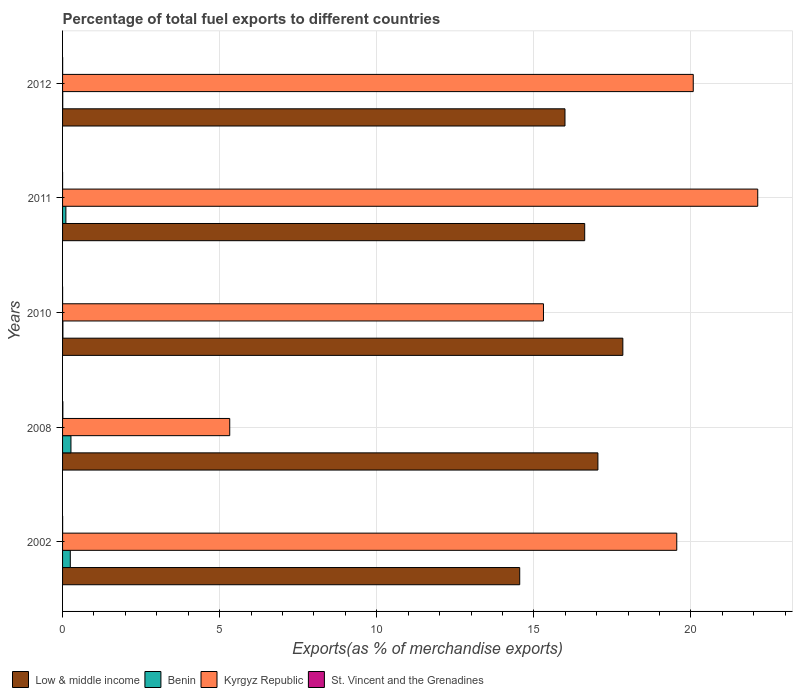How many groups of bars are there?
Offer a very short reply. 5. Are the number of bars on each tick of the Y-axis equal?
Keep it short and to the point. Yes. What is the percentage of exports to different countries in Kyrgyz Republic in 2002?
Your answer should be compact. 19.55. Across all years, what is the maximum percentage of exports to different countries in Kyrgyz Republic?
Your answer should be very brief. 22.12. Across all years, what is the minimum percentage of exports to different countries in Low & middle income?
Give a very brief answer. 14.55. What is the total percentage of exports to different countries in Benin in the graph?
Provide a short and direct response. 0.63. What is the difference between the percentage of exports to different countries in Benin in 2008 and that in 2012?
Give a very brief answer. 0.26. What is the difference between the percentage of exports to different countries in Kyrgyz Republic in 2011 and the percentage of exports to different countries in Benin in 2012?
Make the answer very short. 22.12. What is the average percentage of exports to different countries in Benin per year?
Your answer should be compact. 0.13. In the year 2008, what is the difference between the percentage of exports to different countries in Kyrgyz Republic and percentage of exports to different countries in Low & middle income?
Keep it short and to the point. -11.72. What is the ratio of the percentage of exports to different countries in Benin in 2010 to that in 2012?
Your response must be concise. 2.1. Is the percentage of exports to different countries in Benin in 2011 less than that in 2012?
Offer a terse response. No. What is the difference between the highest and the second highest percentage of exports to different countries in Low & middle income?
Ensure brevity in your answer.  0.79. What is the difference between the highest and the lowest percentage of exports to different countries in Benin?
Your answer should be compact. 0.26. In how many years, is the percentage of exports to different countries in Low & middle income greater than the average percentage of exports to different countries in Low & middle income taken over all years?
Make the answer very short. 3. What does the 4th bar from the top in 2002 represents?
Provide a short and direct response. Low & middle income. What does the 4th bar from the bottom in 2011 represents?
Your answer should be very brief. St. Vincent and the Grenadines. Is it the case that in every year, the sum of the percentage of exports to different countries in Low & middle income and percentage of exports to different countries in St. Vincent and the Grenadines is greater than the percentage of exports to different countries in Benin?
Provide a succinct answer. Yes. How many bars are there?
Ensure brevity in your answer.  20. How are the legend labels stacked?
Keep it short and to the point. Horizontal. What is the title of the graph?
Your response must be concise. Percentage of total fuel exports to different countries. Does "Suriname" appear as one of the legend labels in the graph?
Offer a very short reply. No. What is the label or title of the X-axis?
Make the answer very short. Exports(as % of merchandise exports). What is the Exports(as % of merchandise exports) in Low & middle income in 2002?
Your answer should be very brief. 14.55. What is the Exports(as % of merchandise exports) in Benin in 2002?
Ensure brevity in your answer.  0.25. What is the Exports(as % of merchandise exports) in Kyrgyz Republic in 2002?
Your answer should be compact. 19.55. What is the Exports(as % of merchandise exports) of St. Vincent and the Grenadines in 2002?
Provide a short and direct response. 0. What is the Exports(as % of merchandise exports) of Low & middle income in 2008?
Provide a short and direct response. 17.04. What is the Exports(as % of merchandise exports) of Benin in 2008?
Provide a short and direct response. 0.27. What is the Exports(as % of merchandise exports) of Kyrgyz Republic in 2008?
Make the answer very short. 5.32. What is the Exports(as % of merchandise exports) of St. Vincent and the Grenadines in 2008?
Your response must be concise. 0.01. What is the Exports(as % of merchandise exports) of Low & middle income in 2010?
Ensure brevity in your answer.  17.83. What is the Exports(as % of merchandise exports) of Benin in 2010?
Keep it short and to the point. 0.01. What is the Exports(as % of merchandise exports) of Kyrgyz Republic in 2010?
Make the answer very short. 15.3. What is the Exports(as % of merchandise exports) of St. Vincent and the Grenadines in 2010?
Provide a short and direct response. 0. What is the Exports(as % of merchandise exports) in Low & middle income in 2011?
Provide a succinct answer. 16.62. What is the Exports(as % of merchandise exports) in Benin in 2011?
Keep it short and to the point. 0.11. What is the Exports(as % of merchandise exports) in Kyrgyz Republic in 2011?
Provide a short and direct response. 22.12. What is the Exports(as % of merchandise exports) in St. Vincent and the Grenadines in 2011?
Make the answer very short. 0. What is the Exports(as % of merchandise exports) in Low & middle income in 2012?
Provide a succinct answer. 15.99. What is the Exports(as % of merchandise exports) of Benin in 2012?
Give a very brief answer. 0.01. What is the Exports(as % of merchandise exports) in Kyrgyz Republic in 2012?
Your answer should be compact. 20.07. What is the Exports(as % of merchandise exports) in St. Vincent and the Grenadines in 2012?
Keep it short and to the point. 0. Across all years, what is the maximum Exports(as % of merchandise exports) of Low & middle income?
Offer a terse response. 17.83. Across all years, what is the maximum Exports(as % of merchandise exports) of Benin?
Offer a very short reply. 0.27. Across all years, what is the maximum Exports(as % of merchandise exports) of Kyrgyz Republic?
Make the answer very short. 22.12. Across all years, what is the maximum Exports(as % of merchandise exports) in St. Vincent and the Grenadines?
Provide a succinct answer. 0.01. Across all years, what is the minimum Exports(as % of merchandise exports) in Low & middle income?
Ensure brevity in your answer.  14.55. Across all years, what is the minimum Exports(as % of merchandise exports) in Benin?
Your answer should be very brief. 0.01. Across all years, what is the minimum Exports(as % of merchandise exports) of Kyrgyz Republic?
Give a very brief answer. 5.32. Across all years, what is the minimum Exports(as % of merchandise exports) of St. Vincent and the Grenadines?
Ensure brevity in your answer.  0. What is the total Exports(as % of merchandise exports) of Low & middle income in the graph?
Offer a very short reply. 82.03. What is the total Exports(as % of merchandise exports) of Benin in the graph?
Provide a succinct answer. 0.63. What is the total Exports(as % of merchandise exports) of Kyrgyz Republic in the graph?
Give a very brief answer. 82.37. What is the total Exports(as % of merchandise exports) in St. Vincent and the Grenadines in the graph?
Keep it short and to the point. 0.01. What is the difference between the Exports(as % of merchandise exports) in Low & middle income in 2002 and that in 2008?
Provide a short and direct response. -2.49. What is the difference between the Exports(as % of merchandise exports) in Benin in 2002 and that in 2008?
Your answer should be compact. -0.02. What is the difference between the Exports(as % of merchandise exports) of Kyrgyz Republic in 2002 and that in 2008?
Provide a succinct answer. 14.23. What is the difference between the Exports(as % of merchandise exports) of St. Vincent and the Grenadines in 2002 and that in 2008?
Give a very brief answer. -0.01. What is the difference between the Exports(as % of merchandise exports) in Low & middle income in 2002 and that in 2010?
Provide a succinct answer. -3.28. What is the difference between the Exports(as % of merchandise exports) in Benin in 2002 and that in 2010?
Your answer should be compact. 0.24. What is the difference between the Exports(as % of merchandise exports) of Kyrgyz Republic in 2002 and that in 2010?
Offer a very short reply. 4.24. What is the difference between the Exports(as % of merchandise exports) in St. Vincent and the Grenadines in 2002 and that in 2010?
Give a very brief answer. 0. What is the difference between the Exports(as % of merchandise exports) of Low & middle income in 2002 and that in 2011?
Your response must be concise. -2.07. What is the difference between the Exports(as % of merchandise exports) in Benin in 2002 and that in 2011?
Provide a succinct answer. 0.14. What is the difference between the Exports(as % of merchandise exports) in Kyrgyz Republic in 2002 and that in 2011?
Your answer should be compact. -2.58. What is the difference between the Exports(as % of merchandise exports) of St. Vincent and the Grenadines in 2002 and that in 2011?
Ensure brevity in your answer.  0. What is the difference between the Exports(as % of merchandise exports) in Low & middle income in 2002 and that in 2012?
Provide a succinct answer. -1.44. What is the difference between the Exports(as % of merchandise exports) in Benin in 2002 and that in 2012?
Offer a very short reply. 0.24. What is the difference between the Exports(as % of merchandise exports) of Kyrgyz Republic in 2002 and that in 2012?
Your response must be concise. -0.52. What is the difference between the Exports(as % of merchandise exports) of St. Vincent and the Grenadines in 2002 and that in 2012?
Provide a succinct answer. -0. What is the difference between the Exports(as % of merchandise exports) in Low & middle income in 2008 and that in 2010?
Provide a short and direct response. -0.79. What is the difference between the Exports(as % of merchandise exports) of Benin in 2008 and that in 2010?
Your response must be concise. 0.26. What is the difference between the Exports(as % of merchandise exports) of Kyrgyz Republic in 2008 and that in 2010?
Your answer should be very brief. -9.98. What is the difference between the Exports(as % of merchandise exports) in St. Vincent and the Grenadines in 2008 and that in 2010?
Provide a succinct answer. 0.01. What is the difference between the Exports(as % of merchandise exports) of Low & middle income in 2008 and that in 2011?
Your answer should be very brief. 0.42. What is the difference between the Exports(as % of merchandise exports) of Benin in 2008 and that in 2011?
Give a very brief answer. 0.16. What is the difference between the Exports(as % of merchandise exports) in Kyrgyz Republic in 2008 and that in 2011?
Your answer should be compact. -16.8. What is the difference between the Exports(as % of merchandise exports) in St. Vincent and the Grenadines in 2008 and that in 2011?
Provide a succinct answer. 0.01. What is the difference between the Exports(as % of merchandise exports) of Low & middle income in 2008 and that in 2012?
Your answer should be compact. 1.05. What is the difference between the Exports(as % of merchandise exports) of Benin in 2008 and that in 2012?
Your response must be concise. 0.26. What is the difference between the Exports(as % of merchandise exports) of Kyrgyz Republic in 2008 and that in 2012?
Provide a succinct answer. -14.75. What is the difference between the Exports(as % of merchandise exports) in St. Vincent and the Grenadines in 2008 and that in 2012?
Your answer should be compact. 0.01. What is the difference between the Exports(as % of merchandise exports) in Low & middle income in 2010 and that in 2011?
Offer a terse response. 1.21. What is the difference between the Exports(as % of merchandise exports) of Benin in 2010 and that in 2011?
Offer a terse response. -0.09. What is the difference between the Exports(as % of merchandise exports) in Kyrgyz Republic in 2010 and that in 2011?
Offer a very short reply. -6.82. What is the difference between the Exports(as % of merchandise exports) of St. Vincent and the Grenadines in 2010 and that in 2011?
Offer a terse response. 0. What is the difference between the Exports(as % of merchandise exports) in Low & middle income in 2010 and that in 2012?
Offer a very short reply. 1.84. What is the difference between the Exports(as % of merchandise exports) in Benin in 2010 and that in 2012?
Ensure brevity in your answer.  0.01. What is the difference between the Exports(as % of merchandise exports) of Kyrgyz Republic in 2010 and that in 2012?
Give a very brief answer. -4.77. What is the difference between the Exports(as % of merchandise exports) in St. Vincent and the Grenadines in 2010 and that in 2012?
Provide a succinct answer. -0. What is the difference between the Exports(as % of merchandise exports) of Low & middle income in 2011 and that in 2012?
Your response must be concise. 0.63. What is the difference between the Exports(as % of merchandise exports) in Benin in 2011 and that in 2012?
Your response must be concise. 0.1. What is the difference between the Exports(as % of merchandise exports) of Kyrgyz Republic in 2011 and that in 2012?
Give a very brief answer. 2.05. What is the difference between the Exports(as % of merchandise exports) of St. Vincent and the Grenadines in 2011 and that in 2012?
Provide a short and direct response. -0. What is the difference between the Exports(as % of merchandise exports) of Low & middle income in 2002 and the Exports(as % of merchandise exports) of Benin in 2008?
Provide a succinct answer. 14.28. What is the difference between the Exports(as % of merchandise exports) of Low & middle income in 2002 and the Exports(as % of merchandise exports) of Kyrgyz Republic in 2008?
Your answer should be very brief. 9.23. What is the difference between the Exports(as % of merchandise exports) of Low & middle income in 2002 and the Exports(as % of merchandise exports) of St. Vincent and the Grenadines in 2008?
Provide a succinct answer. 14.54. What is the difference between the Exports(as % of merchandise exports) in Benin in 2002 and the Exports(as % of merchandise exports) in Kyrgyz Republic in 2008?
Provide a succinct answer. -5.07. What is the difference between the Exports(as % of merchandise exports) of Benin in 2002 and the Exports(as % of merchandise exports) of St. Vincent and the Grenadines in 2008?
Keep it short and to the point. 0.24. What is the difference between the Exports(as % of merchandise exports) in Kyrgyz Republic in 2002 and the Exports(as % of merchandise exports) in St. Vincent and the Grenadines in 2008?
Offer a terse response. 19.54. What is the difference between the Exports(as % of merchandise exports) in Low & middle income in 2002 and the Exports(as % of merchandise exports) in Benin in 2010?
Offer a terse response. 14.54. What is the difference between the Exports(as % of merchandise exports) in Low & middle income in 2002 and the Exports(as % of merchandise exports) in Kyrgyz Republic in 2010?
Make the answer very short. -0.76. What is the difference between the Exports(as % of merchandise exports) in Low & middle income in 2002 and the Exports(as % of merchandise exports) in St. Vincent and the Grenadines in 2010?
Your response must be concise. 14.55. What is the difference between the Exports(as % of merchandise exports) in Benin in 2002 and the Exports(as % of merchandise exports) in Kyrgyz Republic in 2010?
Keep it short and to the point. -15.06. What is the difference between the Exports(as % of merchandise exports) of Benin in 2002 and the Exports(as % of merchandise exports) of St. Vincent and the Grenadines in 2010?
Offer a terse response. 0.24. What is the difference between the Exports(as % of merchandise exports) of Kyrgyz Republic in 2002 and the Exports(as % of merchandise exports) of St. Vincent and the Grenadines in 2010?
Your answer should be compact. 19.55. What is the difference between the Exports(as % of merchandise exports) in Low & middle income in 2002 and the Exports(as % of merchandise exports) in Benin in 2011?
Give a very brief answer. 14.44. What is the difference between the Exports(as % of merchandise exports) of Low & middle income in 2002 and the Exports(as % of merchandise exports) of Kyrgyz Republic in 2011?
Keep it short and to the point. -7.58. What is the difference between the Exports(as % of merchandise exports) of Low & middle income in 2002 and the Exports(as % of merchandise exports) of St. Vincent and the Grenadines in 2011?
Keep it short and to the point. 14.55. What is the difference between the Exports(as % of merchandise exports) in Benin in 2002 and the Exports(as % of merchandise exports) in Kyrgyz Republic in 2011?
Your response must be concise. -21.88. What is the difference between the Exports(as % of merchandise exports) of Benin in 2002 and the Exports(as % of merchandise exports) of St. Vincent and the Grenadines in 2011?
Give a very brief answer. 0.25. What is the difference between the Exports(as % of merchandise exports) of Kyrgyz Republic in 2002 and the Exports(as % of merchandise exports) of St. Vincent and the Grenadines in 2011?
Make the answer very short. 19.55. What is the difference between the Exports(as % of merchandise exports) in Low & middle income in 2002 and the Exports(as % of merchandise exports) in Benin in 2012?
Your response must be concise. 14.54. What is the difference between the Exports(as % of merchandise exports) in Low & middle income in 2002 and the Exports(as % of merchandise exports) in Kyrgyz Republic in 2012?
Your response must be concise. -5.52. What is the difference between the Exports(as % of merchandise exports) in Low & middle income in 2002 and the Exports(as % of merchandise exports) in St. Vincent and the Grenadines in 2012?
Offer a terse response. 14.55. What is the difference between the Exports(as % of merchandise exports) in Benin in 2002 and the Exports(as % of merchandise exports) in Kyrgyz Republic in 2012?
Give a very brief answer. -19.83. What is the difference between the Exports(as % of merchandise exports) in Benin in 2002 and the Exports(as % of merchandise exports) in St. Vincent and the Grenadines in 2012?
Keep it short and to the point. 0.24. What is the difference between the Exports(as % of merchandise exports) in Kyrgyz Republic in 2002 and the Exports(as % of merchandise exports) in St. Vincent and the Grenadines in 2012?
Ensure brevity in your answer.  19.55. What is the difference between the Exports(as % of merchandise exports) of Low & middle income in 2008 and the Exports(as % of merchandise exports) of Benin in 2010?
Ensure brevity in your answer.  17.03. What is the difference between the Exports(as % of merchandise exports) in Low & middle income in 2008 and the Exports(as % of merchandise exports) in Kyrgyz Republic in 2010?
Ensure brevity in your answer.  1.73. What is the difference between the Exports(as % of merchandise exports) of Low & middle income in 2008 and the Exports(as % of merchandise exports) of St. Vincent and the Grenadines in 2010?
Give a very brief answer. 17.04. What is the difference between the Exports(as % of merchandise exports) of Benin in 2008 and the Exports(as % of merchandise exports) of Kyrgyz Republic in 2010?
Your answer should be very brief. -15.04. What is the difference between the Exports(as % of merchandise exports) in Benin in 2008 and the Exports(as % of merchandise exports) in St. Vincent and the Grenadines in 2010?
Your answer should be compact. 0.27. What is the difference between the Exports(as % of merchandise exports) of Kyrgyz Republic in 2008 and the Exports(as % of merchandise exports) of St. Vincent and the Grenadines in 2010?
Make the answer very short. 5.32. What is the difference between the Exports(as % of merchandise exports) in Low & middle income in 2008 and the Exports(as % of merchandise exports) in Benin in 2011?
Your response must be concise. 16.93. What is the difference between the Exports(as % of merchandise exports) in Low & middle income in 2008 and the Exports(as % of merchandise exports) in Kyrgyz Republic in 2011?
Provide a short and direct response. -5.09. What is the difference between the Exports(as % of merchandise exports) of Low & middle income in 2008 and the Exports(as % of merchandise exports) of St. Vincent and the Grenadines in 2011?
Provide a succinct answer. 17.04. What is the difference between the Exports(as % of merchandise exports) in Benin in 2008 and the Exports(as % of merchandise exports) in Kyrgyz Republic in 2011?
Your answer should be very brief. -21.86. What is the difference between the Exports(as % of merchandise exports) in Benin in 2008 and the Exports(as % of merchandise exports) in St. Vincent and the Grenadines in 2011?
Keep it short and to the point. 0.27. What is the difference between the Exports(as % of merchandise exports) of Kyrgyz Republic in 2008 and the Exports(as % of merchandise exports) of St. Vincent and the Grenadines in 2011?
Ensure brevity in your answer.  5.32. What is the difference between the Exports(as % of merchandise exports) in Low & middle income in 2008 and the Exports(as % of merchandise exports) in Benin in 2012?
Your response must be concise. 17.03. What is the difference between the Exports(as % of merchandise exports) in Low & middle income in 2008 and the Exports(as % of merchandise exports) in Kyrgyz Republic in 2012?
Provide a short and direct response. -3.03. What is the difference between the Exports(as % of merchandise exports) of Low & middle income in 2008 and the Exports(as % of merchandise exports) of St. Vincent and the Grenadines in 2012?
Your response must be concise. 17.04. What is the difference between the Exports(as % of merchandise exports) in Benin in 2008 and the Exports(as % of merchandise exports) in Kyrgyz Republic in 2012?
Your answer should be very brief. -19.81. What is the difference between the Exports(as % of merchandise exports) of Benin in 2008 and the Exports(as % of merchandise exports) of St. Vincent and the Grenadines in 2012?
Provide a short and direct response. 0.26. What is the difference between the Exports(as % of merchandise exports) of Kyrgyz Republic in 2008 and the Exports(as % of merchandise exports) of St. Vincent and the Grenadines in 2012?
Ensure brevity in your answer.  5.32. What is the difference between the Exports(as % of merchandise exports) of Low & middle income in 2010 and the Exports(as % of merchandise exports) of Benin in 2011?
Provide a short and direct response. 17.73. What is the difference between the Exports(as % of merchandise exports) in Low & middle income in 2010 and the Exports(as % of merchandise exports) in Kyrgyz Republic in 2011?
Give a very brief answer. -4.29. What is the difference between the Exports(as % of merchandise exports) of Low & middle income in 2010 and the Exports(as % of merchandise exports) of St. Vincent and the Grenadines in 2011?
Ensure brevity in your answer.  17.83. What is the difference between the Exports(as % of merchandise exports) in Benin in 2010 and the Exports(as % of merchandise exports) in Kyrgyz Republic in 2011?
Offer a very short reply. -22.11. What is the difference between the Exports(as % of merchandise exports) of Benin in 2010 and the Exports(as % of merchandise exports) of St. Vincent and the Grenadines in 2011?
Your answer should be very brief. 0.01. What is the difference between the Exports(as % of merchandise exports) of Kyrgyz Republic in 2010 and the Exports(as % of merchandise exports) of St. Vincent and the Grenadines in 2011?
Offer a very short reply. 15.3. What is the difference between the Exports(as % of merchandise exports) of Low & middle income in 2010 and the Exports(as % of merchandise exports) of Benin in 2012?
Offer a terse response. 17.83. What is the difference between the Exports(as % of merchandise exports) in Low & middle income in 2010 and the Exports(as % of merchandise exports) in Kyrgyz Republic in 2012?
Your answer should be very brief. -2.24. What is the difference between the Exports(as % of merchandise exports) of Low & middle income in 2010 and the Exports(as % of merchandise exports) of St. Vincent and the Grenadines in 2012?
Keep it short and to the point. 17.83. What is the difference between the Exports(as % of merchandise exports) of Benin in 2010 and the Exports(as % of merchandise exports) of Kyrgyz Republic in 2012?
Offer a terse response. -20.06. What is the difference between the Exports(as % of merchandise exports) of Benin in 2010 and the Exports(as % of merchandise exports) of St. Vincent and the Grenadines in 2012?
Keep it short and to the point. 0.01. What is the difference between the Exports(as % of merchandise exports) in Kyrgyz Republic in 2010 and the Exports(as % of merchandise exports) in St. Vincent and the Grenadines in 2012?
Offer a terse response. 15.3. What is the difference between the Exports(as % of merchandise exports) of Low & middle income in 2011 and the Exports(as % of merchandise exports) of Benin in 2012?
Keep it short and to the point. 16.61. What is the difference between the Exports(as % of merchandise exports) of Low & middle income in 2011 and the Exports(as % of merchandise exports) of Kyrgyz Republic in 2012?
Provide a short and direct response. -3.45. What is the difference between the Exports(as % of merchandise exports) in Low & middle income in 2011 and the Exports(as % of merchandise exports) in St. Vincent and the Grenadines in 2012?
Provide a succinct answer. 16.62. What is the difference between the Exports(as % of merchandise exports) of Benin in 2011 and the Exports(as % of merchandise exports) of Kyrgyz Republic in 2012?
Give a very brief answer. -19.97. What is the difference between the Exports(as % of merchandise exports) in Benin in 2011 and the Exports(as % of merchandise exports) in St. Vincent and the Grenadines in 2012?
Keep it short and to the point. 0.1. What is the difference between the Exports(as % of merchandise exports) in Kyrgyz Republic in 2011 and the Exports(as % of merchandise exports) in St. Vincent and the Grenadines in 2012?
Ensure brevity in your answer.  22.12. What is the average Exports(as % of merchandise exports) of Low & middle income per year?
Offer a very short reply. 16.41. What is the average Exports(as % of merchandise exports) of Benin per year?
Offer a very short reply. 0.13. What is the average Exports(as % of merchandise exports) in Kyrgyz Republic per year?
Your answer should be compact. 16.47. What is the average Exports(as % of merchandise exports) of St. Vincent and the Grenadines per year?
Your answer should be very brief. 0. In the year 2002, what is the difference between the Exports(as % of merchandise exports) of Low & middle income and Exports(as % of merchandise exports) of Benin?
Make the answer very short. 14.3. In the year 2002, what is the difference between the Exports(as % of merchandise exports) of Low & middle income and Exports(as % of merchandise exports) of Kyrgyz Republic?
Offer a very short reply. -5. In the year 2002, what is the difference between the Exports(as % of merchandise exports) of Low & middle income and Exports(as % of merchandise exports) of St. Vincent and the Grenadines?
Give a very brief answer. 14.55. In the year 2002, what is the difference between the Exports(as % of merchandise exports) of Benin and Exports(as % of merchandise exports) of Kyrgyz Republic?
Offer a terse response. -19.3. In the year 2002, what is the difference between the Exports(as % of merchandise exports) in Benin and Exports(as % of merchandise exports) in St. Vincent and the Grenadines?
Ensure brevity in your answer.  0.24. In the year 2002, what is the difference between the Exports(as % of merchandise exports) in Kyrgyz Republic and Exports(as % of merchandise exports) in St. Vincent and the Grenadines?
Offer a very short reply. 19.55. In the year 2008, what is the difference between the Exports(as % of merchandise exports) in Low & middle income and Exports(as % of merchandise exports) in Benin?
Your answer should be compact. 16.77. In the year 2008, what is the difference between the Exports(as % of merchandise exports) of Low & middle income and Exports(as % of merchandise exports) of Kyrgyz Republic?
Ensure brevity in your answer.  11.72. In the year 2008, what is the difference between the Exports(as % of merchandise exports) in Low & middle income and Exports(as % of merchandise exports) in St. Vincent and the Grenadines?
Your response must be concise. 17.03. In the year 2008, what is the difference between the Exports(as % of merchandise exports) of Benin and Exports(as % of merchandise exports) of Kyrgyz Republic?
Your response must be concise. -5.05. In the year 2008, what is the difference between the Exports(as % of merchandise exports) in Benin and Exports(as % of merchandise exports) in St. Vincent and the Grenadines?
Provide a succinct answer. 0.26. In the year 2008, what is the difference between the Exports(as % of merchandise exports) in Kyrgyz Republic and Exports(as % of merchandise exports) in St. Vincent and the Grenadines?
Your answer should be compact. 5.31. In the year 2010, what is the difference between the Exports(as % of merchandise exports) in Low & middle income and Exports(as % of merchandise exports) in Benin?
Provide a succinct answer. 17.82. In the year 2010, what is the difference between the Exports(as % of merchandise exports) in Low & middle income and Exports(as % of merchandise exports) in Kyrgyz Republic?
Provide a succinct answer. 2.53. In the year 2010, what is the difference between the Exports(as % of merchandise exports) in Low & middle income and Exports(as % of merchandise exports) in St. Vincent and the Grenadines?
Keep it short and to the point. 17.83. In the year 2010, what is the difference between the Exports(as % of merchandise exports) in Benin and Exports(as % of merchandise exports) in Kyrgyz Republic?
Your response must be concise. -15.29. In the year 2010, what is the difference between the Exports(as % of merchandise exports) in Benin and Exports(as % of merchandise exports) in St. Vincent and the Grenadines?
Provide a succinct answer. 0.01. In the year 2010, what is the difference between the Exports(as % of merchandise exports) of Kyrgyz Republic and Exports(as % of merchandise exports) of St. Vincent and the Grenadines?
Your answer should be very brief. 15.3. In the year 2011, what is the difference between the Exports(as % of merchandise exports) in Low & middle income and Exports(as % of merchandise exports) in Benin?
Provide a succinct answer. 16.51. In the year 2011, what is the difference between the Exports(as % of merchandise exports) in Low & middle income and Exports(as % of merchandise exports) in Kyrgyz Republic?
Give a very brief answer. -5.51. In the year 2011, what is the difference between the Exports(as % of merchandise exports) in Low & middle income and Exports(as % of merchandise exports) in St. Vincent and the Grenadines?
Keep it short and to the point. 16.62. In the year 2011, what is the difference between the Exports(as % of merchandise exports) in Benin and Exports(as % of merchandise exports) in Kyrgyz Republic?
Offer a terse response. -22.02. In the year 2011, what is the difference between the Exports(as % of merchandise exports) of Benin and Exports(as % of merchandise exports) of St. Vincent and the Grenadines?
Ensure brevity in your answer.  0.11. In the year 2011, what is the difference between the Exports(as % of merchandise exports) in Kyrgyz Republic and Exports(as % of merchandise exports) in St. Vincent and the Grenadines?
Provide a short and direct response. 22.12. In the year 2012, what is the difference between the Exports(as % of merchandise exports) in Low & middle income and Exports(as % of merchandise exports) in Benin?
Make the answer very short. 15.98. In the year 2012, what is the difference between the Exports(as % of merchandise exports) of Low & middle income and Exports(as % of merchandise exports) of Kyrgyz Republic?
Your answer should be compact. -4.08. In the year 2012, what is the difference between the Exports(as % of merchandise exports) in Low & middle income and Exports(as % of merchandise exports) in St. Vincent and the Grenadines?
Ensure brevity in your answer.  15.99. In the year 2012, what is the difference between the Exports(as % of merchandise exports) in Benin and Exports(as % of merchandise exports) in Kyrgyz Republic?
Your response must be concise. -20.07. In the year 2012, what is the difference between the Exports(as % of merchandise exports) of Benin and Exports(as % of merchandise exports) of St. Vincent and the Grenadines?
Offer a very short reply. 0. In the year 2012, what is the difference between the Exports(as % of merchandise exports) of Kyrgyz Republic and Exports(as % of merchandise exports) of St. Vincent and the Grenadines?
Ensure brevity in your answer.  20.07. What is the ratio of the Exports(as % of merchandise exports) in Low & middle income in 2002 to that in 2008?
Keep it short and to the point. 0.85. What is the ratio of the Exports(as % of merchandise exports) of Benin in 2002 to that in 2008?
Make the answer very short. 0.92. What is the ratio of the Exports(as % of merchandise exports) of Kyrgyz Republic in 2002 to that in 2008?
Your answer should be very brief. 3.67. What is the ratio of the Exports(as % of merchandise exports) of St. Vincent and the Grenadines in 2002 to that in 2008?
Ensure brevity in your answer.  0.19. What is the ratio of the Exports(as % of merchandise exports) of Low & middle income in 2002 to that in 2010?
Offer a very short reply. 0.82. What is the ratio of the Exports(as % of merchandise exports) in Benin in 2002 to that in 2010?
Give a very brief answer. 22.91. What is the ratio of the Exports(as % of merchandise exports) in Kyrgyz Republic in 2002 to that in 2010?
Provide a short and direct response. 1.28. What is the ratio of the Exports(as % of merchandise exports) in St. Vincent and the Grenadines in 2002 to that in 2010?
Give a very brief answer. 1.81. What is the ratio of the Exports(as % of merchandise exports) in Low & middle income in 2002 to that in 2011?
Offer a terse response. 0.88. What is the ratio of the Exports(as % of merchandise exports) in Benin in 2002 to that in 2011?
Provide a short and direct response. 2.33. What is the ratio of the Exports(as % of merchandise exports) in Kyrgyz Republic in 2002 to that in 2011?
Give a very brief answer. 0.88. What is the ratio of the Exports(as % of merchandise exports) in St. Vincent and the Grenadines in 2002 to that in 2011?
Your response must be concise. 4.43. What is the ratio of the Exports(as % of merchandise exports) in Low & middle income in 2002 to that in 2012?
Offer a terse response. 0.91. What is the ratio of the Exports(as % of merchandise exports) of Benin in 2002 to that in 2012?
Offer a very short reply. 48.03. What is the ratio of the Exports(as % of merchandise exports) of Kyrgyz Republic in 2002 to that in 2012?
Your answer should be very brief. 0.97. What is the ratio of the Exports(as % of merchandise exports) of St. Vincent and the Grenadines in 2002 to that in 2012?
Offer a terse response. 0.84. What is the ratio of the Exports(as % of merchandise exports) of Low & middle income in 2008 to that in 2010?
Your response must be concise. 0.96. What is the ratio of the Exports(as % of merchandise exports) of Benin in 2008 to that in 2010?
Give a very brief answer. 24.86. What is the ratio of the Exports(as % of merchandise exports) of Kyrgyz Republic in 2008 to that in 2010?
Make the answer very short. 0.35. What is the ratio of the Exports(as % of merchandise exports) in St. Vincent and the Grenadines in 2008 to that in 2010?
Your answer should be compact. 9.34. What is the ratio of the Exports(as % of merchandise exports) in Low & middle income in 2008 to that in 2011?
Your answer should be compact. 1.03. What is the ratio of the Exports(as % of merchandise exports) in Benin in 2008 to that in 2011?
Provide a short and direct response. 2.53. What is the ratio of the Exports(as % of merchandise exports) in Kyrgyz Republic in 2008 to that in 2011?
Your answer should be very brief. 0.24. What is the ratio of the Exports(as % of merchandise exports) in St. Vincent and the Grenadines in 2008 to that in 2011?
Offer a very short reply. 22.86. What is the ratio of the Exports(as % of merchandise exports) in Low & middle income in 2008 to that in 2012?
Your answer should be very brief. 1.07. What is the ratio of the Exports(as % of merchandise exports) of Benin in 2008 to that in 2012?
Provide a succinct answer. 52.11. What is the ratio of the Exports(as % of merchandise exports) of Kyrgyz Republic in 2008 to that in 2012?
Offer a very short reply. 0.27. What is the ratio of the Exports(as % of merchandise exports) in St. Vincent and the Grenadines in 2008 to that in 2012?
Offer a terse response. 4.32. What is the ratio of the Exports(as % of merchandise exports) of Low & middle income in 2010 to that in 2011?
Make the answer very short. 1.07. What is the ratio of the Exports(as % of merchandise exports) of Benin in 2010 to that in 2011?
Keep it short and to the point. 0.1. What is the ratio of the Exports(as % of merchandise exports) of Kyrgyz Republic in 2010 to that in 2011?
Offer a very short reply. 0.69. What is the ratio of the Exports(as % of merchandise exports) of St. Vincent and the Grenadines in 2010 to that in 2011?
Offer a terse response. 2.45. What is the ratio of the Exports(as % of merchandise exports) of Low & middle income in 2010 to that in 2012?
Ensure brevity in your answer.  1.12. What is the ratio of the Exports(as % of merchandise exports) in Benin in 2010 to that in 2012?
Make the answer very short. 2.1. What is the ratio of the Exports(as % of merchandise exports) in Kyrgyz Republic in 2010 to that in 2012?
Offer a very short reply. 0.76. What is the ratio of the Exports(as % of merchandise exports) in St. Vincent and the Grenadines in 2010 to that in 2012?
Your answer should be compact. 0.46. What is the ratio of the Exports(as % of merchandise exports) in Low & middle income in 2011 to that in 2012?
Keep it short and to the point. 1.04. What is the ratio of the Exports(as % of merchandise exports) of Benin in 2011 to that in 2012?
Your answer should be compact. 20.62. What is the ratio of the Exports(as % of merchandise exports) in Kyrgyz Republic in 2011 to that in 2012?
Offer a terse response. 1.1. What is the ratio of the Exports(as % of merchandise exports) of St. Vincent and the Grenadines in 2011 to that in 2012?
Your response must be concise. 0.19. What is the difference between the highest and the second highest Exports(as % of merchandise exports) in Low & middle income?
Make the answer very short. 0.79. What is the difference between the highest and the second highest Exports(as % of merchandise exports) of Benin?
Make the answer very short. 0.02. What is the difference between the highest and the second highest Exports(as % of merchandise exports) in Kyrgyz Republic?
Keep it short and to the point. 2.05. What is the difference between the highest and the second highest Exports(as % of merchandise exports) in St. Vincent and the Grenadines?
Offer a very short reply. 0.01. What is the difference between the highest and the lowest Exports(as % of merchandise exports) of Low & middle income?
Keep it short and to the point. 3.28. What is the difference between the highest and the lowest Exports(as % of merchandise exports) of Benin?
Provide a short and direct response. 0.26. What is the difference between the highest and the lowest Exports(as % of merchandise exports) in Kyrgyz Republic?
Make the answer very short. 16.8. What is the difference between the highest and the lowest Exports(as % of merchandise exports) in St. Vincent and the Grenadines?
Your answer should be very brief. 0.01. 